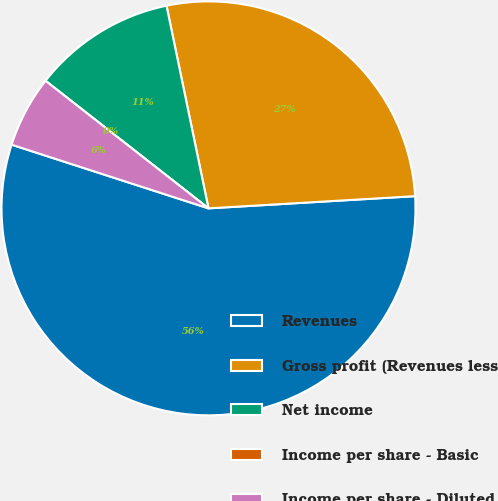Convert chart to OTSL. <chart><loc_0><loc_0><loc_500><loc_500><pie_chart><fcel>Revenues<fcel>Gross profit (Revenues less<fcel>Net income<fcel>Income per share - Basic<fcel>Income per share - Diluted<nl><fcel>55.91%<fcel>27.31%<fcel>11.18%<fcel>0.0%<fcel>5.59%<nl></chart> 